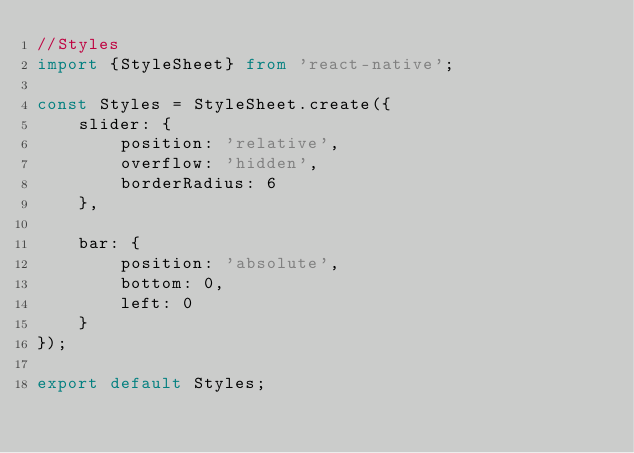<code> <loc_0><loc_0><loc_500><loc_500><_TypeScript_>//Styles
import {StyleSheet} from 'react-native';

const Styles = StyleSheet.create({
    slider: {
        position: 'relative',
        overflow: 'hidden',
        borderRadius: 6
    },

    bar: {
        position: 'absolute',
        bottom: 0,
        left: 0
    }
});

export default Styles;</code> 